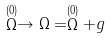Convert formula to latex. <formula><loc_0><loc_0><loc_500><loc_500>\stackrel { ( 0 ) } { \Omega } \rightarrow \Omega = \stackrel { ( 0 ) } { \Omega } + g</formula> 